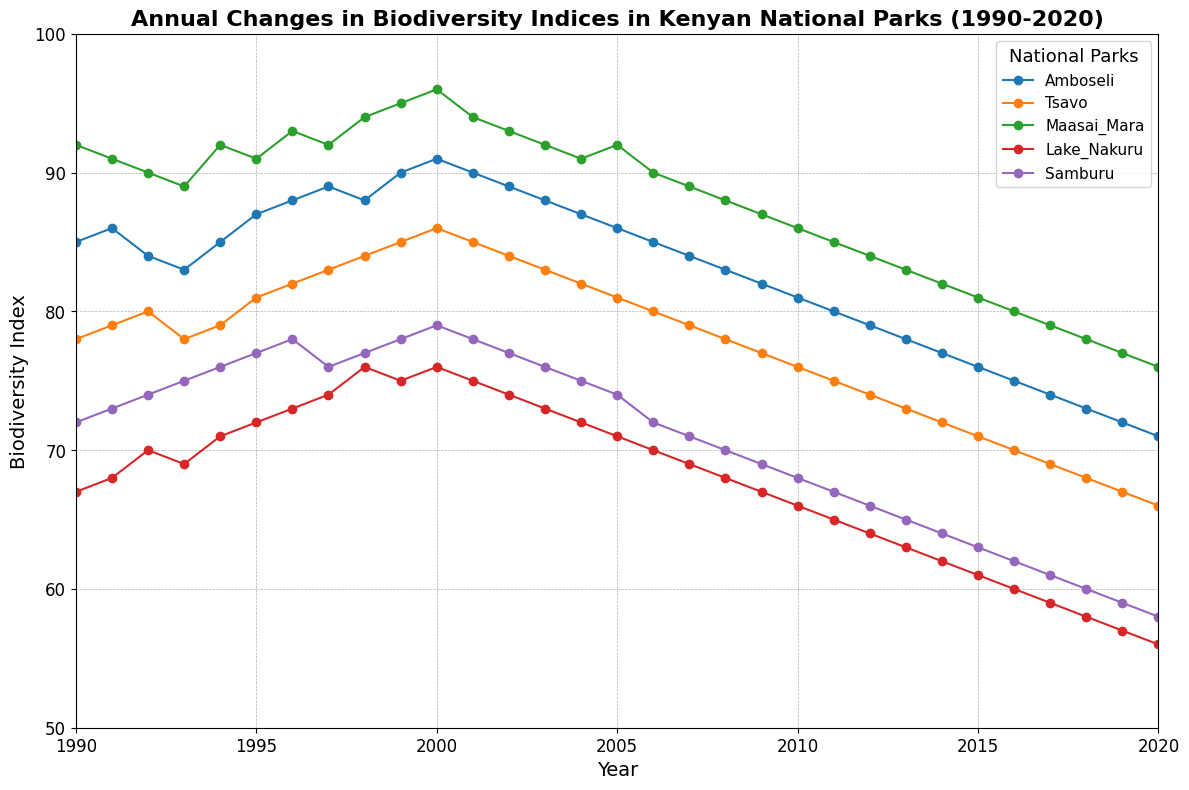What was the biodiversity index for Maasai Mara in the year 2000? Locate the year 2000 on the x-axis and find the corresponding point for Maasai Mara on the plot, then read the y-axis value.
Answer: 96 Which national park had the highest biodiversity index in 1995? Find the year 1995 on the x-axis, then compare the y-axis values for each national park at that year.
Answer: Maasai Mara By how much did the biodiversity index of Amboseli change from 1990 to 2020? Locate the points for Amboseli in 1990 and 2020, and subtract the y-value in 2020 from the y-value in 1990 to find the change.
Answer: -14 Between Tsavo and Samburu, which park experienced a greater decrease in biodiversity index from 2010 to 2020? Calculate the difference in the y-values for Tsavo and Samburu between 2010 and 2020, then compare the two differences.
Answer: Tsavo What is the average biodiversity index for Lake Nakuru from 1990 to 2020? Sum the biodiversity indices for Lake Nakuru from 1990 to 2020 and divide by the number of years (31).
Answer: 66.55 During which year did Maasai Mara peak in biodiversity index, and what was the value? Look for the highest point along the Maasai Mara line on the plot and read off the corresponding year and y-value.
Answer: 2000, 96 How do the trends of biodiversity indices for Amboseli and Samburu compare over the period from 1990 to 2020? Observe the line trends for Amboseli and Samburu; Amboseli shows a steady decline while Samburu also declines but with less steepness.
Answer: Amboseli declined more sharply What visual difference can you see between the biodiversity index trends of Maasai Mara and Lake Nakuru? Identify the line for Maasai Mara and note its relatively higher values and peaks compared to the more steady and lower trend line of Lake Nakuru.
Answer: Maasai Mara is higher and more variable Calculate the difference in biodiversity index between Tsavo and Samburu in the year 1998. Find the y-values for Tsavo and Samburu in 1998 and subtract the value for Samburu from the value for Tsavo to get the difference.
Answer: 7 Which national park shows the least variability in its biodiversity index from 1990 to 2020? Observe each park's line and find the one with the smallest range between its highest and lowest points.
Answer: Tsavo 